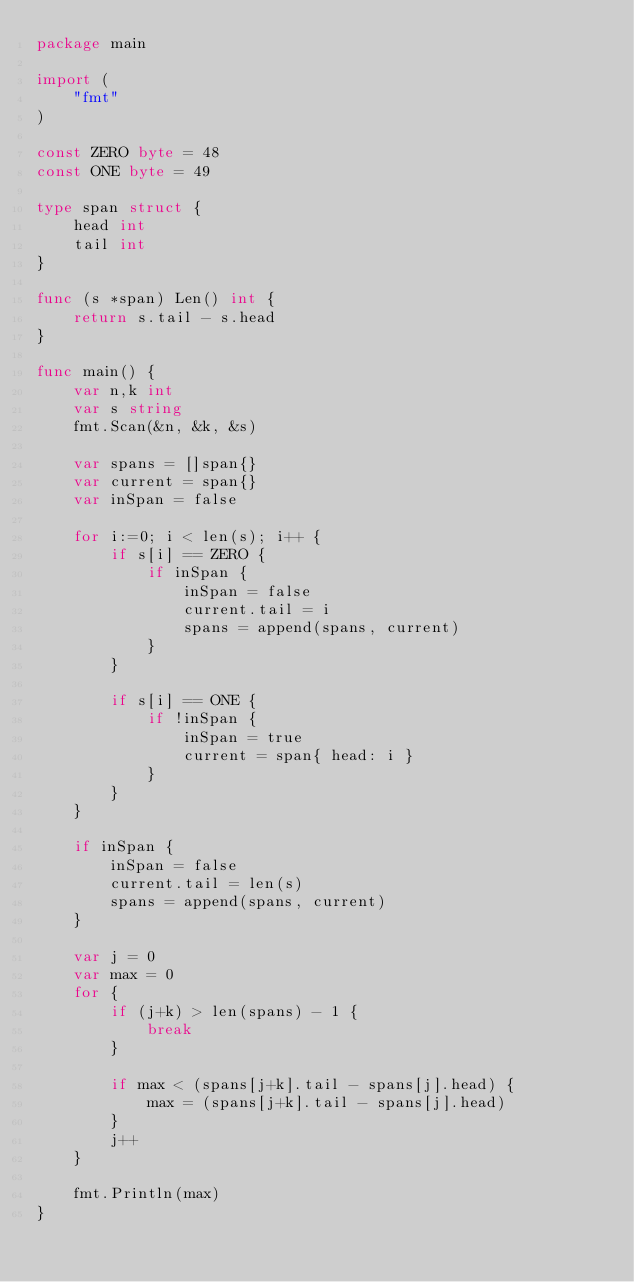<code> <loc_0><loc_0><loc_500><loc_500><_Go_>package main

import (
    "fmt"
)

const ZERO byte = 48
const ONE byte = 49

type span struct {
    head int
    tail int
}

func (s *span) Len() int {
    return s.tail - s.head
}

func main() {
    var n,k int
    var s string
    fmt.Scan(&n, &k, &s)

    var spans = []span{}
    var current = span{}
    var inSpan = false

    for i:=0; i < len(s); i++ {
        if s[i] == ZERO {
            if inSpan {
                inSpan = false
                current.tail = i
                spans = append(spans, current)
            }
        }

        if s[i] == ONE {
            if !inSpan {
                inSpan = true
                current = span{ head: i }
            }
        }
    }

    if inSpan {
        inSpan = false
        current.tail = len(s)
        spans = append(spans, current)
    }

    var j = 0
    var max = 0
    for {
        if (j+k) > len(spans) - 1 {
            break
        }

        if max < (spans[j+k].tail - spans[j].head) {
            max = (spans[j+k].tail - spans[j].head)
        }
        j++
    }

    fmt.Println(max)
}
</code> 